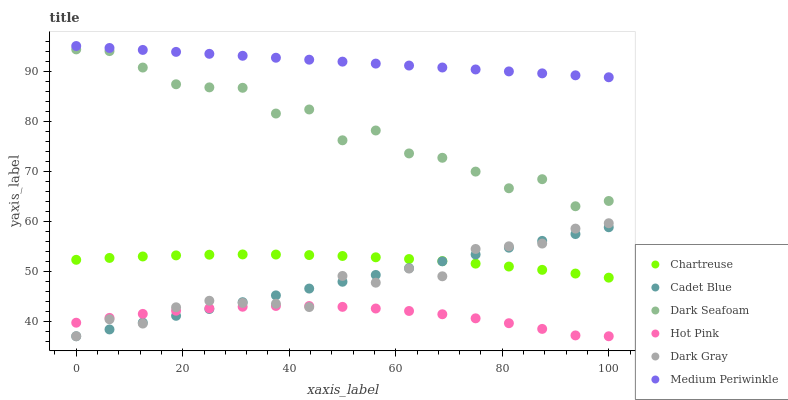Does Hot Pink have the minimum area under the curve?
Answer yes or no. Yes. Does Medium Periwinkle have the maximum area under the curve?
Answer yes or no. Yes. Does Medium Periwinkle have the minimum area under the curve?
Answer yes or no. No. Does Hot Pink have the maximum area under the curve?
Answer yes or no. No. Is Cadet Blue the smoothest?
Answer yes or no. Yes. Is Dark Seafoam the roughest?
Answer yes or no. Yes. Is Hot Pink the smoothest?
Answer yes or no. No. Is Hot Pink the roughest?
Answer yes or no. No. Does Cadet Blue have the lowest value?
Answer yes or no. Yes. Does Medium Periwinkle have the lowest value?
Answer yes or no. No. Does Medium Periwinkle have the highest value?
Answer yes or no. Yes. Does Hot Pink have the highest value?
Answer yes or no. No. Is Hot Pink less than Chartreuse?
Answer yes or no. Yes. Is Chartreuse greater than Hot Pink?
Answer yes or no. Yes. Does Cadet Blue intersect Dark Gray?
Answer yes or no. Yes. Is Cadet Blue less than Dark Gray?
Answer yes or no. No. Is Cadet Blue greater than Dark Gray?
Answer yes or no. No. Does Hot Pink intersect Chartreuse?
Answer yes or no. No. 